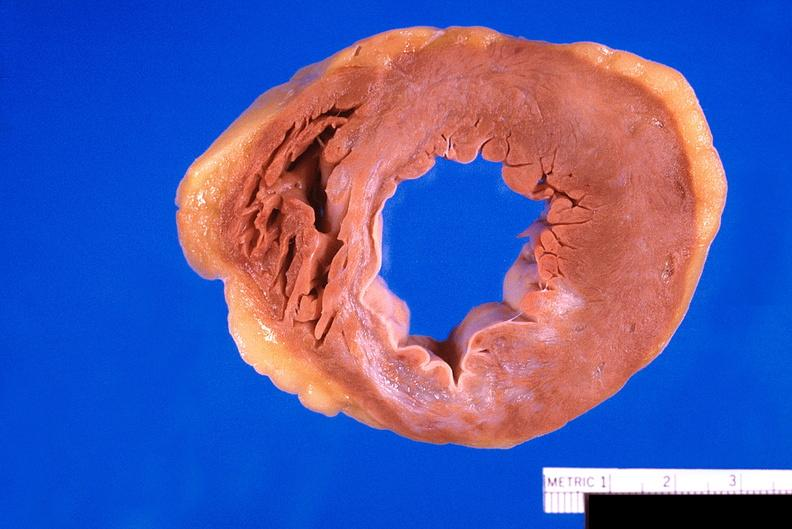does this image show heart, old myocardial infarction with fibrosis?
Answer the question using a single word or phrase. Yes 